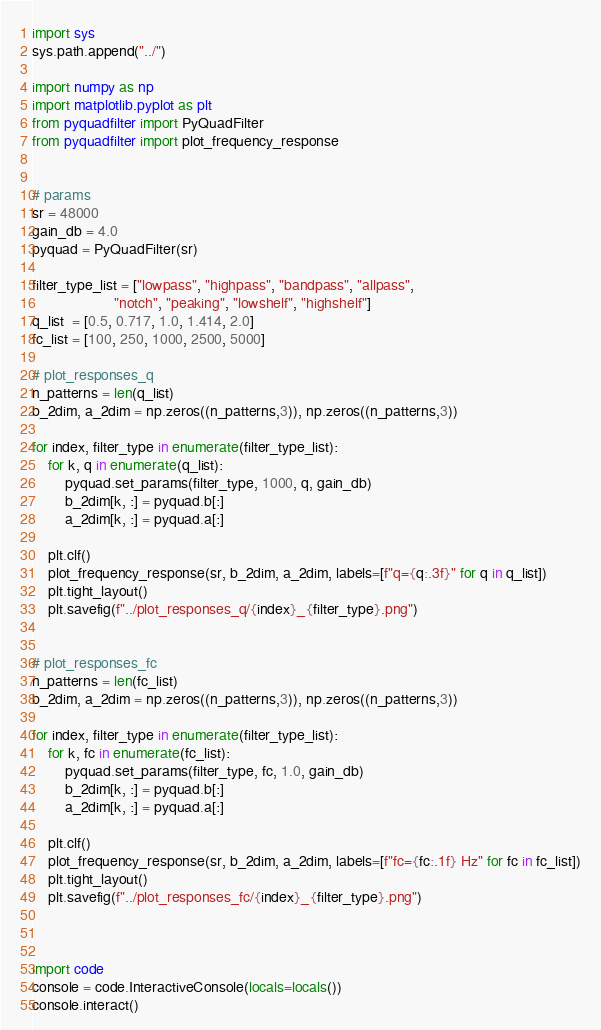Convert code to text. <code><loc_0><loc_0><loc_500><loc_500><_Python_>import sys
sys.path.append("../")

import numpy as np
import matplotlib.pyplot as plt
from pyquadfilter import PyQuadFilter
from pyquadfilter import plot_frequency_response


# params
sr = 48000
gain_db = 4.0
pyquad = PyQuadFilter(sr)

filter_type_list = ["lowpass", "highpass", "bandpass", "allpass",
                    "notch", "peaking", "lowshelf", "highshelf"]
q_list  = [0.5, 0.717, 1.0, 1.414, 2.0]
fc_list = [100, 250, 1000, 2500, 5000]

# plot_responses_q
n_patterns = len(q_list) 
b_2dim, a_2dim = np.zeros((n_patterns,3)), np.zeros((n_patterns,3))

for index, filter_type in enumerate(filter_type_list):
    for k, q in enumerate(q_list):
        pyquad.set_params(filter_type, 1000, q, gain_db)
        b_2dim[k, :] = pyquad.b[:]
        a_2dim[k, :] = pyquad.a[:]
    
    plt.clf()
    plot_frequency_response(sr, b_2dim, a_2dim, labels=[f"q={q:.3f}" for q in q_list])
    plt.tight_layout()
    plt.savefig(f"../plot_responses_q/{index}_{filter_type}.png")


# plot_responses_fc
n_patterns = len(fc_list) 
b_2dim, a_2dim = np.zeros((n_patterns,3)), np.zeros((n_patterns,3))

for index, filter_type in enumerate(filter_type_list):
    for k, fc in enumerate(fc_list):
        pyquad.set_params(filter_type, fc, 1.0, gain_db)
        b_2dim[k, :] = pyquad.b[:]
        a_2dim[k, :] = pyquad.a[:]
    
    plt.clf()
    plot_frequency_response(sr, b_2dim, a_2dim, labels=[f"fc={fc:.1f} Hz" for fc in fc_list])
    plt.tight_layout()
    plt.savefig(f"../plot_responses_fc/{index}_{filter_type}.png")



import code
console = code.InteractiveConsole(locals=locals())
console.interact()</code> 